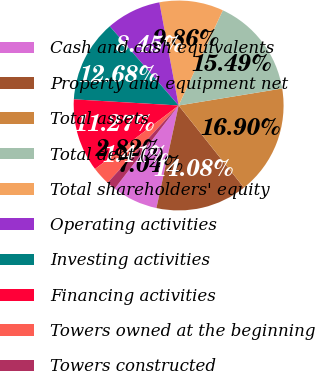Convert chart to OTSL. <chart><loc_0><loc_0><loc_500><loc_500><pie_chart><fcel>Cash and cash equivalents<fcel>Property and equipment net<fcel>Total assets<fcel>Total debt (2)<fcel>Total shareholders' equity<fcel>Operating activities<fcel>Investing activities<fcel>Financing activities<fcel>Towers owned at the beginning<fcel>Towers constructed<nl><fcel>7.04%<fcel>14.08%<fcel>16.9%<fcel>15.49%<fcel>9.86%<fcel>8.45%<fcel>12.68%<fcel>11.27%<fcel>2.82%<fcel>1.41%<nl></chart> 